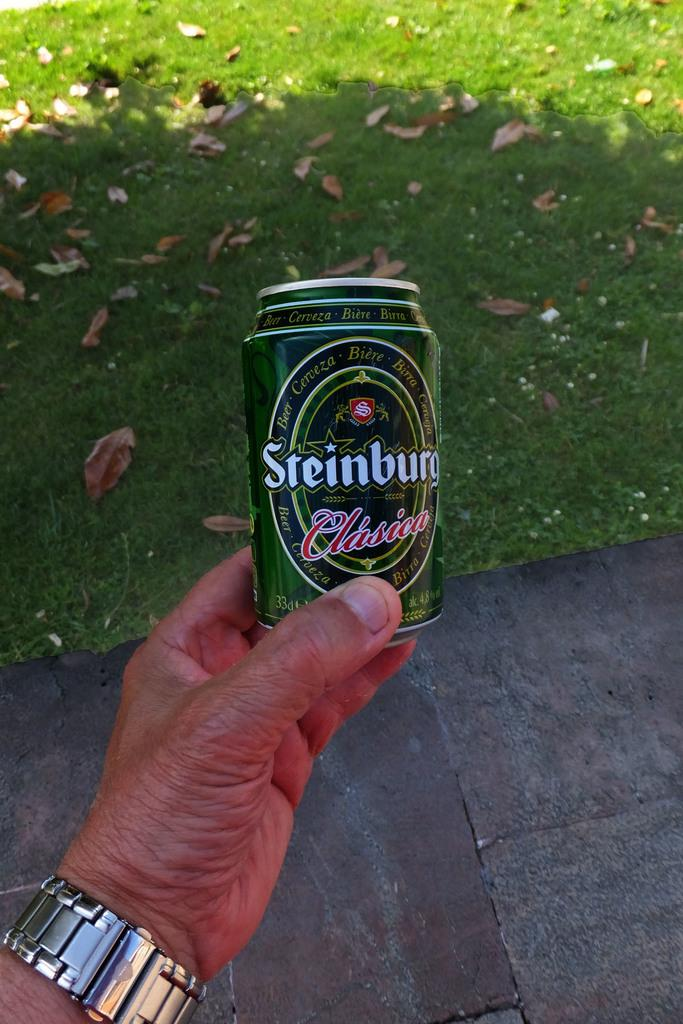Provide a one-sentence caption for the provided image. A man is holding a can of Steinburg beer in his hand. 